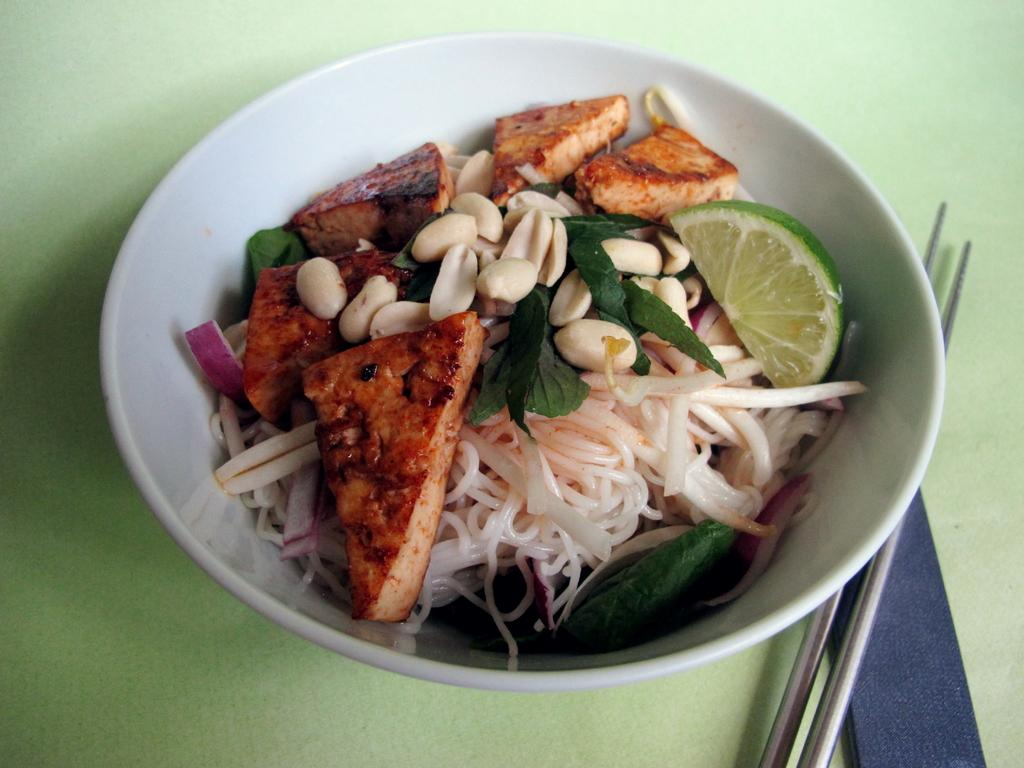What type of furniture is present in the image? There is a table in the image. What is placed on the table? There is a white color bowl on the table. What utensils are present on the table? Two chopsticks are placed on the table. What items can be found inside the bowl? The bowl contains bread slices, noodles, a lemon, peanuts, and leaves. Can you describe the thrill experienced by the robin in the image? There is no robin present in the image, so it is not possible to describe any thrill experienced by a robin. 